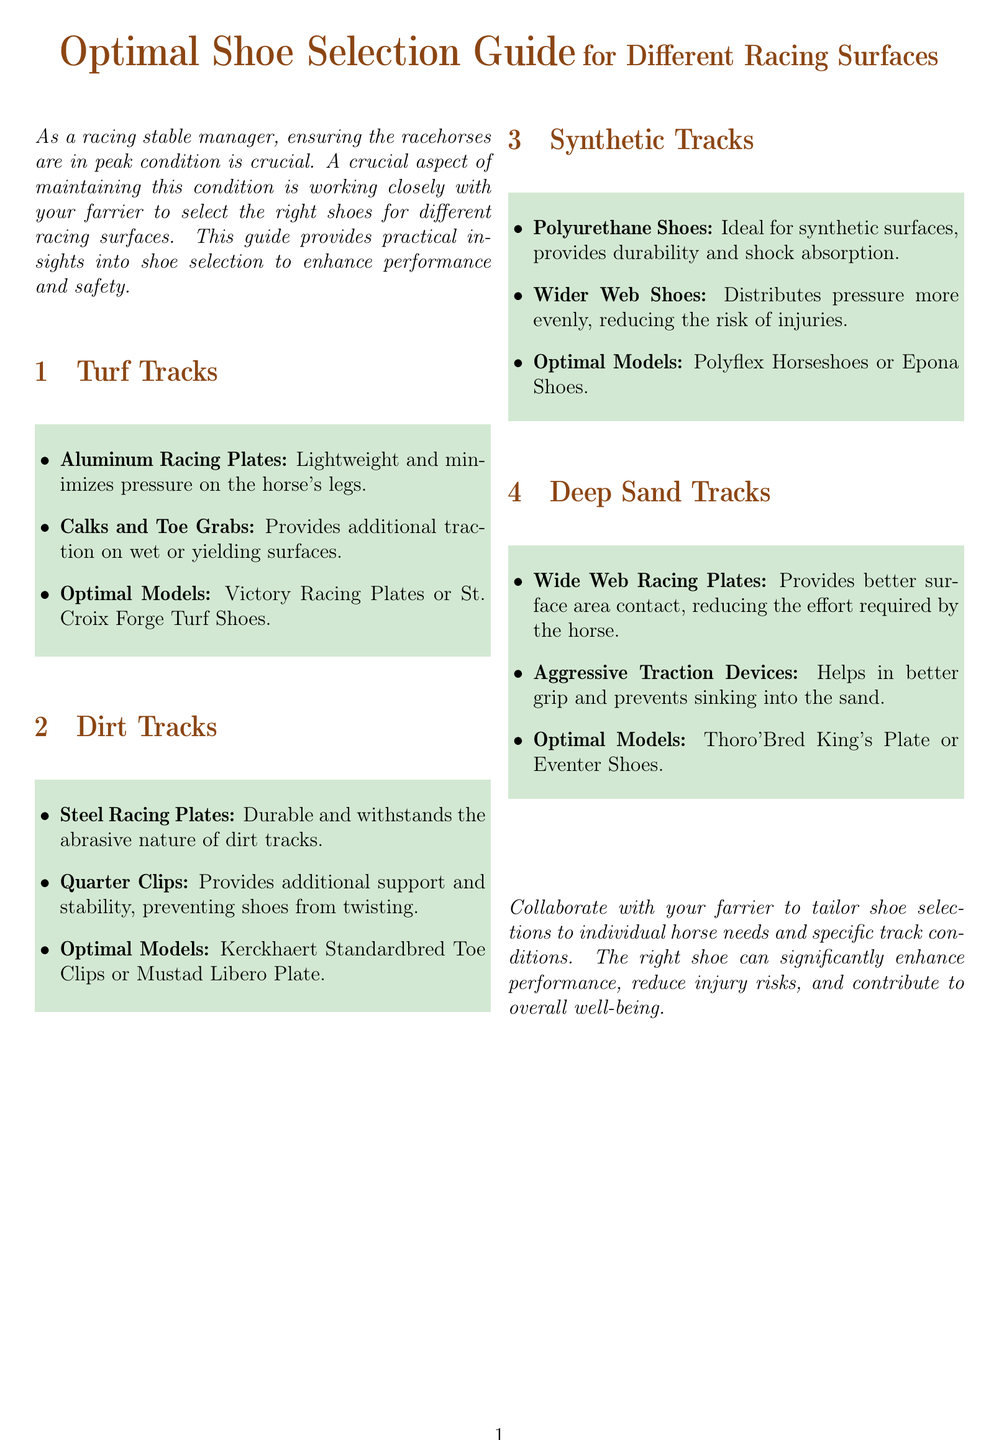What type of plates are optimal for turf tracks? The document states that aluminum racing plates are lightweight and minimize pressure on the horse's legs, making them optimal for turf tracks.
Answer: Aluminum Racing Plates What provides better surface area contact on deep sand tracks? It mentions that wide web racing plates provide better surface area contact, reducing the effort required by the horse.
Answer: Wide Web Racing Plates Which shoes are recommended for synthetic tracks? The document lists Polyflex Horseshoes or Epona Shoes as optimal models for synthetic surfaces.
Answer: Polyflex Horseshoes or Epona Shoes What traction features are suggested for turf tracks? The guide advises using calks and toe grabs to provide additional traction on wet or yielding surfaces.
Answer: Calks and Toe Grabs What type of racing plates are recommended for dirt tracks? The document suggests steel racing plates as durable options for dirt tracks.
Answer: Steel Racing Plates Which device is suggested for better grip on deep sand tracks? The guide recommends using aggressive traction devices to help with grip on deep sand tracks.
Answer: Aggressive Traction Devices What is the purpose of quarter clips on dirt tracks? The document states that quarter clips provide additional support and stability, preventing shoes from twisting.
Answer: Additional support and stability How many racing surfaces are covered in this guide? The document outlines four different racing surfaces where optimal shoe selection is discussed.
Answer: Four What is the main focus of the guide? The guide emphasizes collaborating with the farrier to tailor shoe selections to individual horse needs and specific track conditions.
Answer: Collaborating with your farrier 